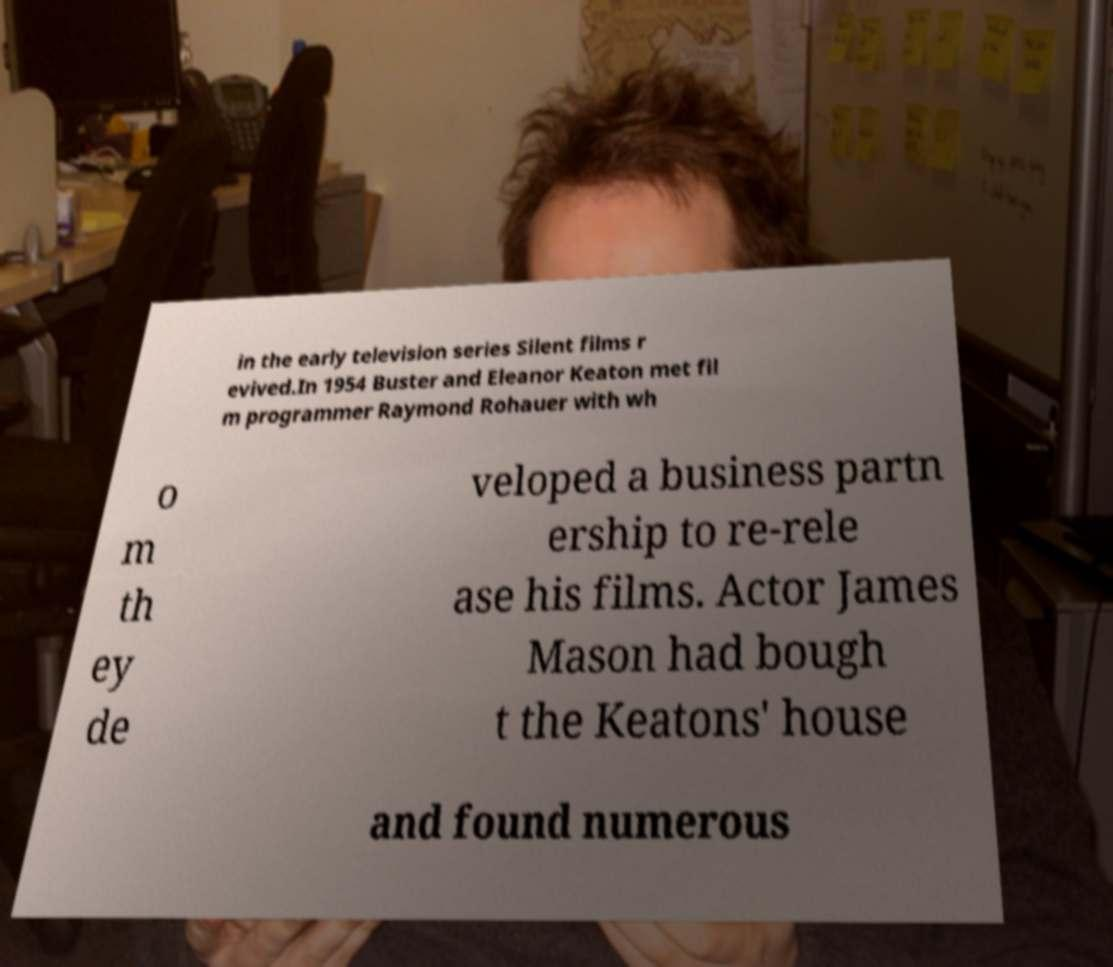Please read and relay the text visible in this image. What does it say? in the early television series Silent films r evived.In 1954 Buster and Eleanor Keaton met fil m programmer Raymond Rohauer with wh o m th ey de veloped a business partn ership to re-rele ase his films. Actor James Mason had bough t the Keatons' house and found numerous 